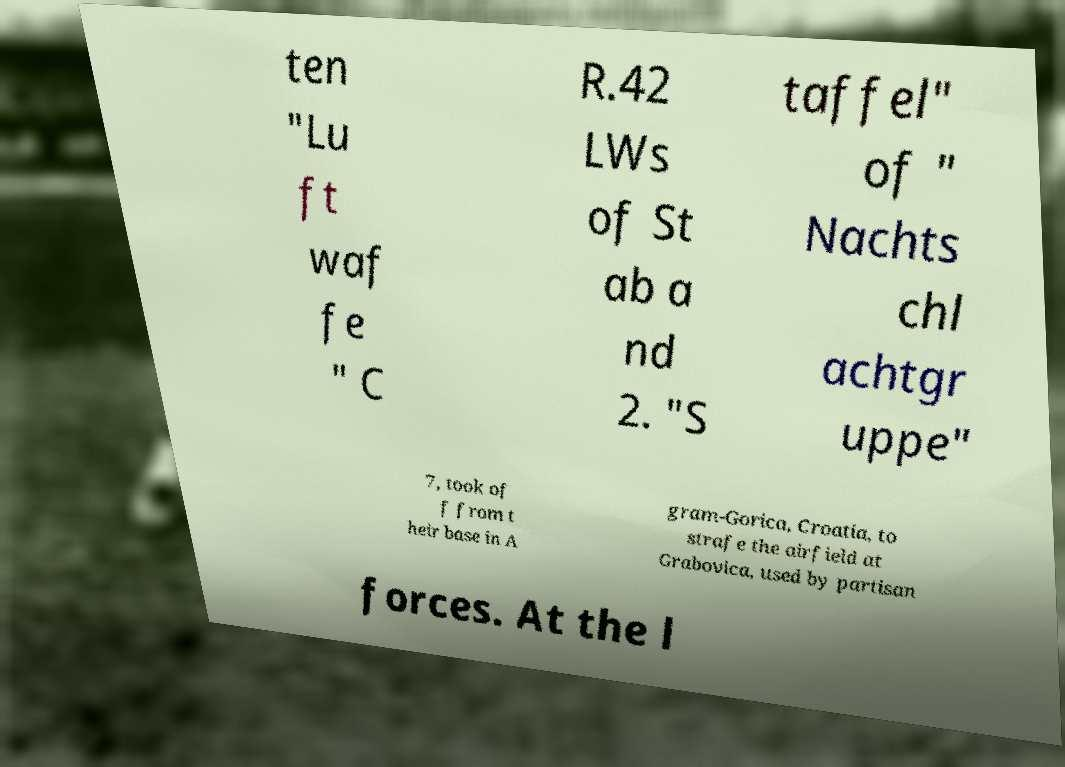Can you accurately transcribe the text from the provided image for me? ten "Lu ft waf fe " C R.42 LWs of St ab a nd 2. "S taffel" of " Nachts chl achtgr uppe" 7, took of f from t heir base in A gram-Gorica, Croatia, to strafe the airfield at Grabovica, used by partisan forces. At the l 